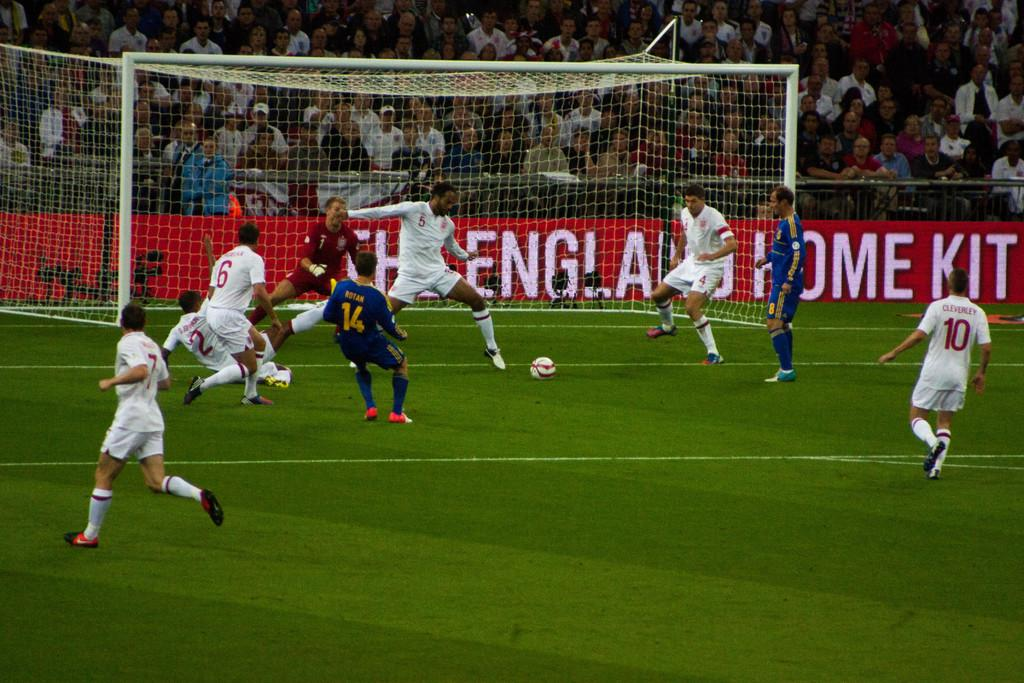<image>
Summarize the visual content of the image. some players on a field with an England sign behind them 